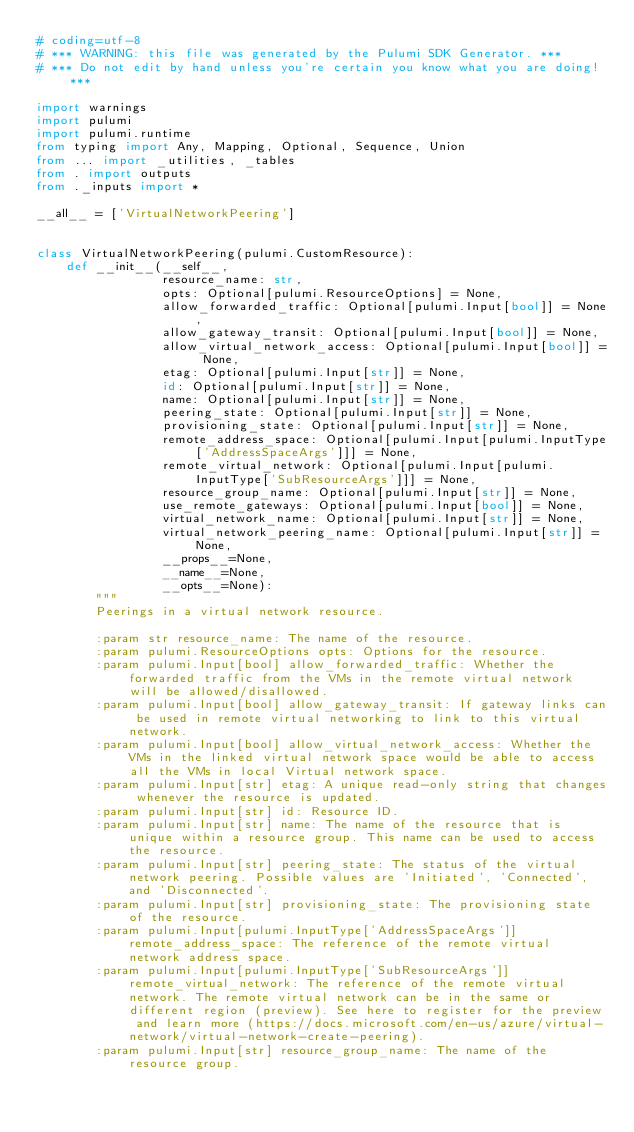Convert code to text. <code><loc_0><loc_0><loc_500><loc_500><_Python_># coding=utf-8
# *** WARNING: this file was generated by the Pulumi SDK Generator. ***
# *** Do not edit by hand unless you're certain you know what you are doing! ***

import warnings
import pulumi
import pulumi.runtime
from typing import Any, Mapping, Optional, Sequence, Union
from ... import _utilities, _tables
from . import outputs
from ._inputs import *

__all__ = ['VirtualNetworkPeering']


class VirtualNetworkPeering(pulumi.CustomResource):
    def __init__(__self__,
                 resource_name: str,
                 opts: Optional[pulumi.ResourceOptions] = None,
                 allow_forwarded_traffic: Optional[pulumi.Input[bool]] = None,
                 allow_gateway_transit: Optional[pulumi.Input[bool]] = None,
                 allow_virtual_network_access: Optional[pulumi.Input[bool]] = None,
                 etag: Optional[pulumi.Input[str]] = None,
                 id: Optional[pulumi.Input[str]] = None,
                 name: Optional[pulumi.Input[str]] = None,
                 peering_state: Optional[pulumi.Input[str]] = None,
                 provisioning_state: Optional[pulumi.Input[str]] = None,
                 remote_address_space: Optional[pulumi.Input[pulumi.InputType['AddressSpaceArgs']]] = None,
                 remote_virtual_network: Optional[pulumi.Input[pulumi.InputType['SubResourceArgs']]] = None,
                 resource_group_name: Optional[pulumi.Input[str]] = None,
                 use_remote_gateways: Optional[pulumi.Input[bool]] = None,
                 virtual_network_name: Optional[pulumi.Input[str]] = None,
                 virtual_network_peering_name: Optional[pulumi.Input[str]] = None,
                 __props__=None,
                 __name__=None,
                 __opts__=None):
        """
        Peerings in a virtual network resource.

        :param str resource_name: The name of the resource.
        :param pulumi.ResourceOptions opts: Options for the resource.
        :param pulumi.Input[bool] allow_forwarded_traffic: Whether the forwarded traffic from the VMs in the remote virtual network will be allowed/disallowed.
        :param pulumi.Input[bool] allow_gateway_transit: If gateway links can be used in remote virtual networking to link to this virtual network.
        :param pulumi.Input[bool] allow_virtual_network_access: Whether the VMs in the linked virtual network space would be able to access all the VMs in local Virtual network space.
        :param pulumi.Input[str] etag: A unique read-only string that changes whenever the resource is updated.
        :param pulumi.Input[str] id: Resource ID.
        :param pulumi.Input[str] name: The name of the resource that is unique within a resource group. This name can be used to access the resource.
        :param pulumi.Input[str] peering_state: The status of the virtual network peering. Possible values are 'Initiated', 'Connected', and 'Disconnected'.
        :param pulumi.Input[str] provisioning_state: The provisioning state of the resource.
        :param pulumi.Input[pulumi.InputType['AddressSpaceArgs']] remote_address_space: The reference of the remote virtual network address space.
        :param pulumi.Input[pulumi.InputType['SubResourceArgs']] remote_virtual_network: The reference of the remote virtual network. The remote virtual network can be in the same or different region (preview). See here to register for the preview and learn more (https://docs.microsoft.com/en-us/azure/virtual-network/virtual-network-create-peering).
        :param pulumi.Input[str] resource_group_name: The name of the resource group.</code> 